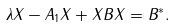Convert formula to latex. <formula><loc_0><loc_0><loc_500><loc_500>\lambda X - A _ { 1 } X + X B X = B ^ { * } .</formula> 